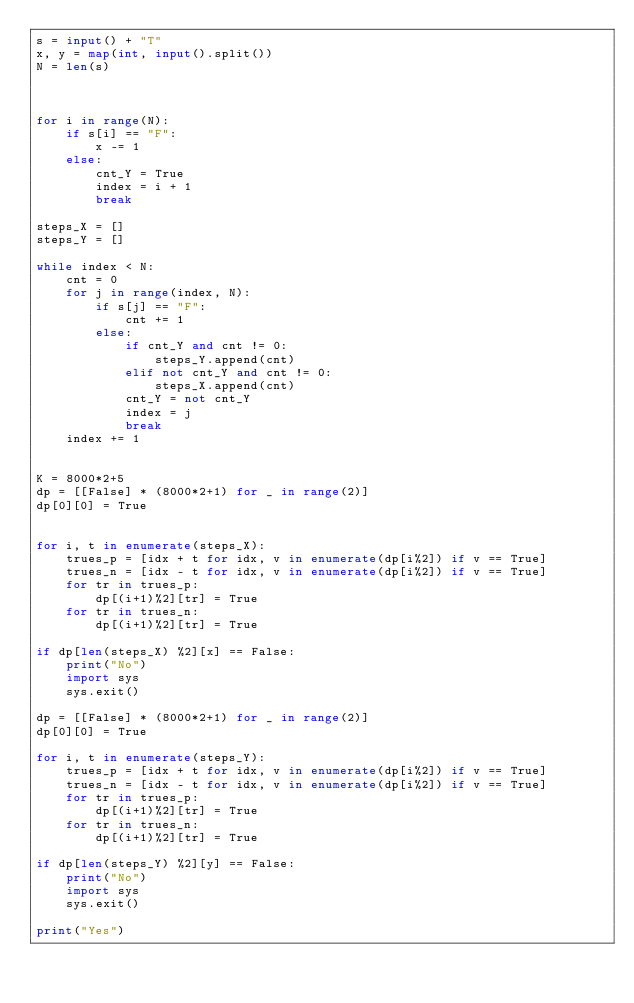Convert code to text. <code><loc_0><loc_0><loc_500><loc_500><_Python_>s = input() + "T"
x, y = map(int, input().split())
N = len(s)



for i in range(N):
    if s[i] == "F":
        x -= 1
    else:
        cnt_Y = True
        index = i + 1
        break

steps_X = []
steps_Y = []

while index < N:
    cnt = 0
    for j in range(index, N):
        if s[j] == "F":
            cnt += 1
        else:
            if cnt_Y and cnt != 0:
                steps_Y.append(cnt)
            elif not cnt_Y and cnt != 0:
                steps_X.append(cnt)
            cnt_Y = not cnt_Y
            index = j
            break
    index += 1


K = 8000*2+5
dp = [[False] * (8000*2+1) for _ in range(2)]
dp[0][0] = True


for i, t in enumerate(steps_X):
    trues_p = [idx + t for idx, v in enumerate(dp[i%2]) if v == True]
    trues_n = [idx - t for idx, v in enumerate(dp[i%2]) if v == True]
    for tr in trues_p:
        dp[(i+1)%2][tr] = True
    for tr in trues_n:
        dp[(i+1)%2][tr] = True

if dp[len(steps_X) %2][x] == False:
    print("No")
    import sys
    sys.exit()

dp = [[False] * (8000*2+1) for _ in range(2)]
dp[0][0] = True

for i, t in enumerate(steps_Y):
    trues_p = [idx + t for idx, v in enumerate(dp[i%2]) if v == True]
    trues_n = [idx - t for idx, v in enumerate(dp[i%2]) if v == True]
    for tr in trues_p:
        dp[(i+1)%2][tr] = True
    for tr in trues_n:
        dp[(i+1)%2][tr] = True

if dp[len(steps_Y) %2][y] == False:
    print("No")
    import sys
    sys.exit()

print("Yes")</code> 